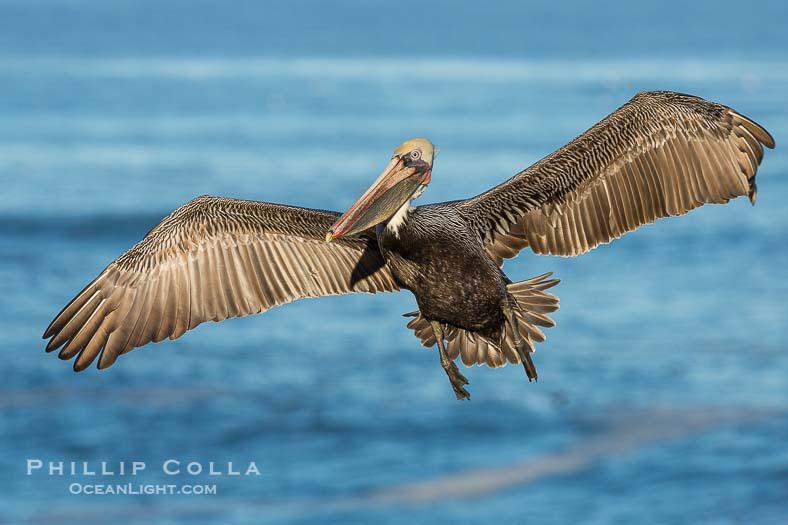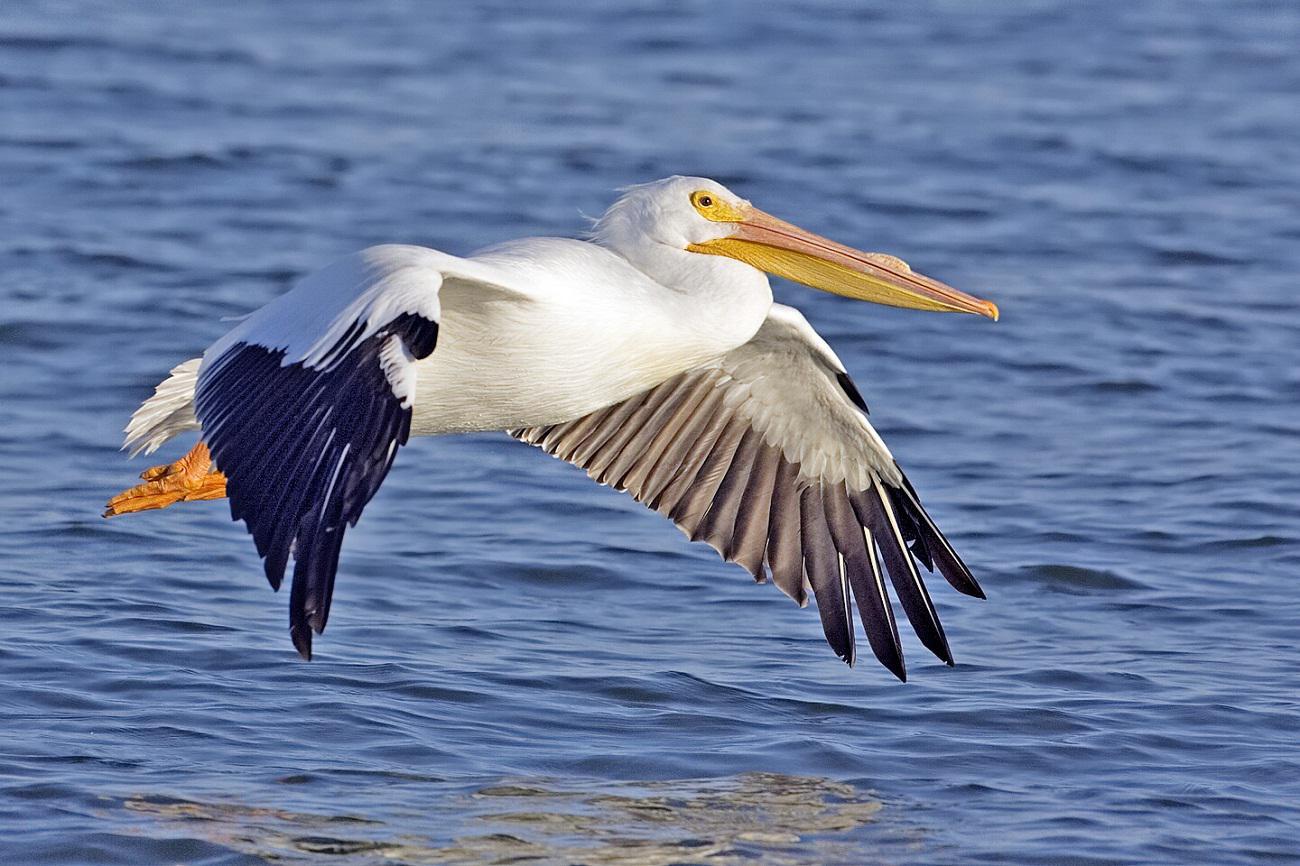The first image is the image on the left, the second image is the image on the right. Considering the images on both sides, is "The bird in the right image is facing towards the left." valid? Answer yes or no. No. The first image is the image on the left, the second image is the image on the right. For the images shown, is this caption "A single bird is flying over the water in the image on the left." true? Answer yes or no. Yes. 